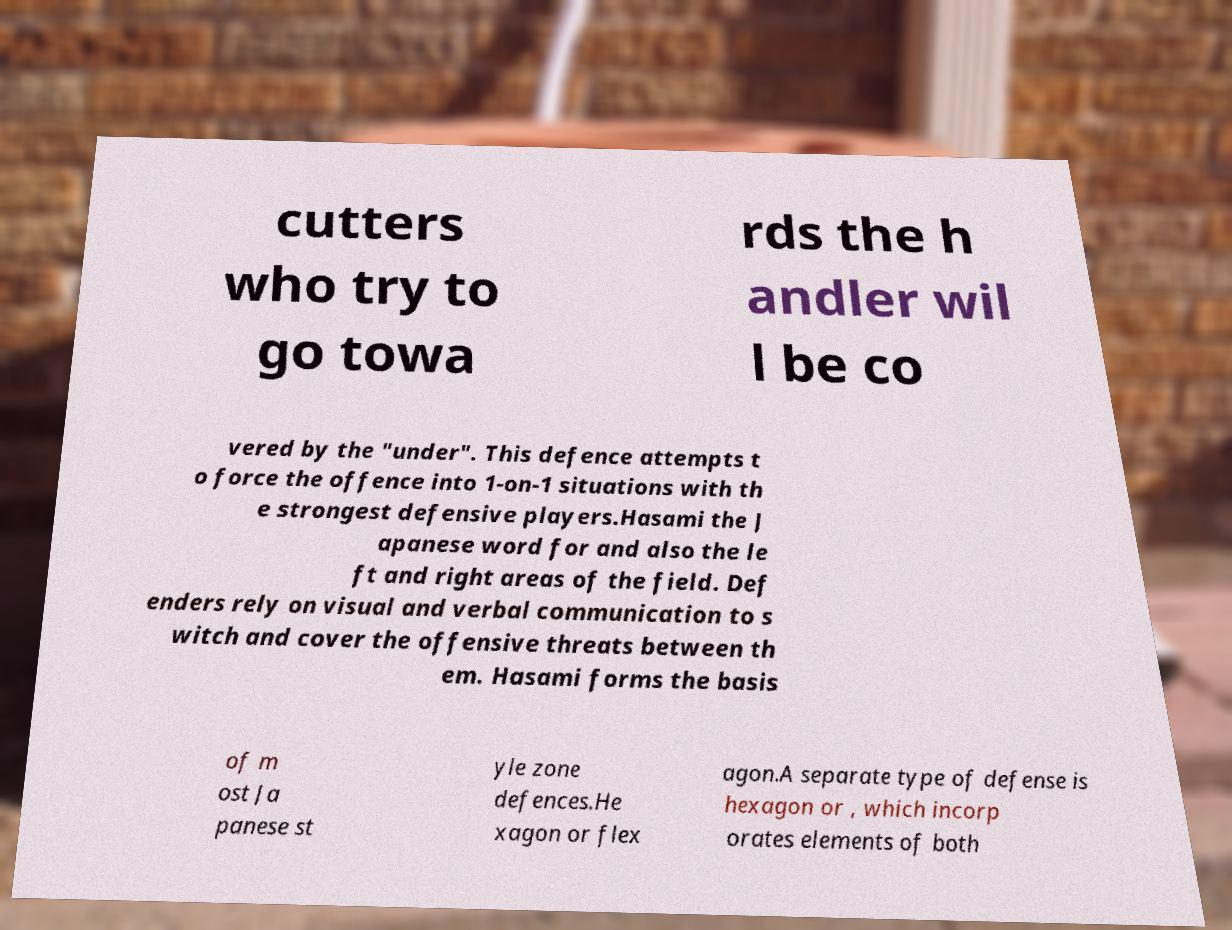Could you extract and type out the text from this image? cutters who try to go towa rds the h andler wil l be co vered by the "under". This defence attempts t o force the offence into 1-on-1 situations with th e strongest defensive players.Hasami the J apanese word for and also the le ft and right areas of the field. Def enders rely on visual and verbal communication to s witch and cover the offensive threats between th em. Hasami forms the basis of m ost Ja panese st yle zone defences.He xagon or flex agon.A separate type of defense is hexagon or , which incorp orates elements of both 